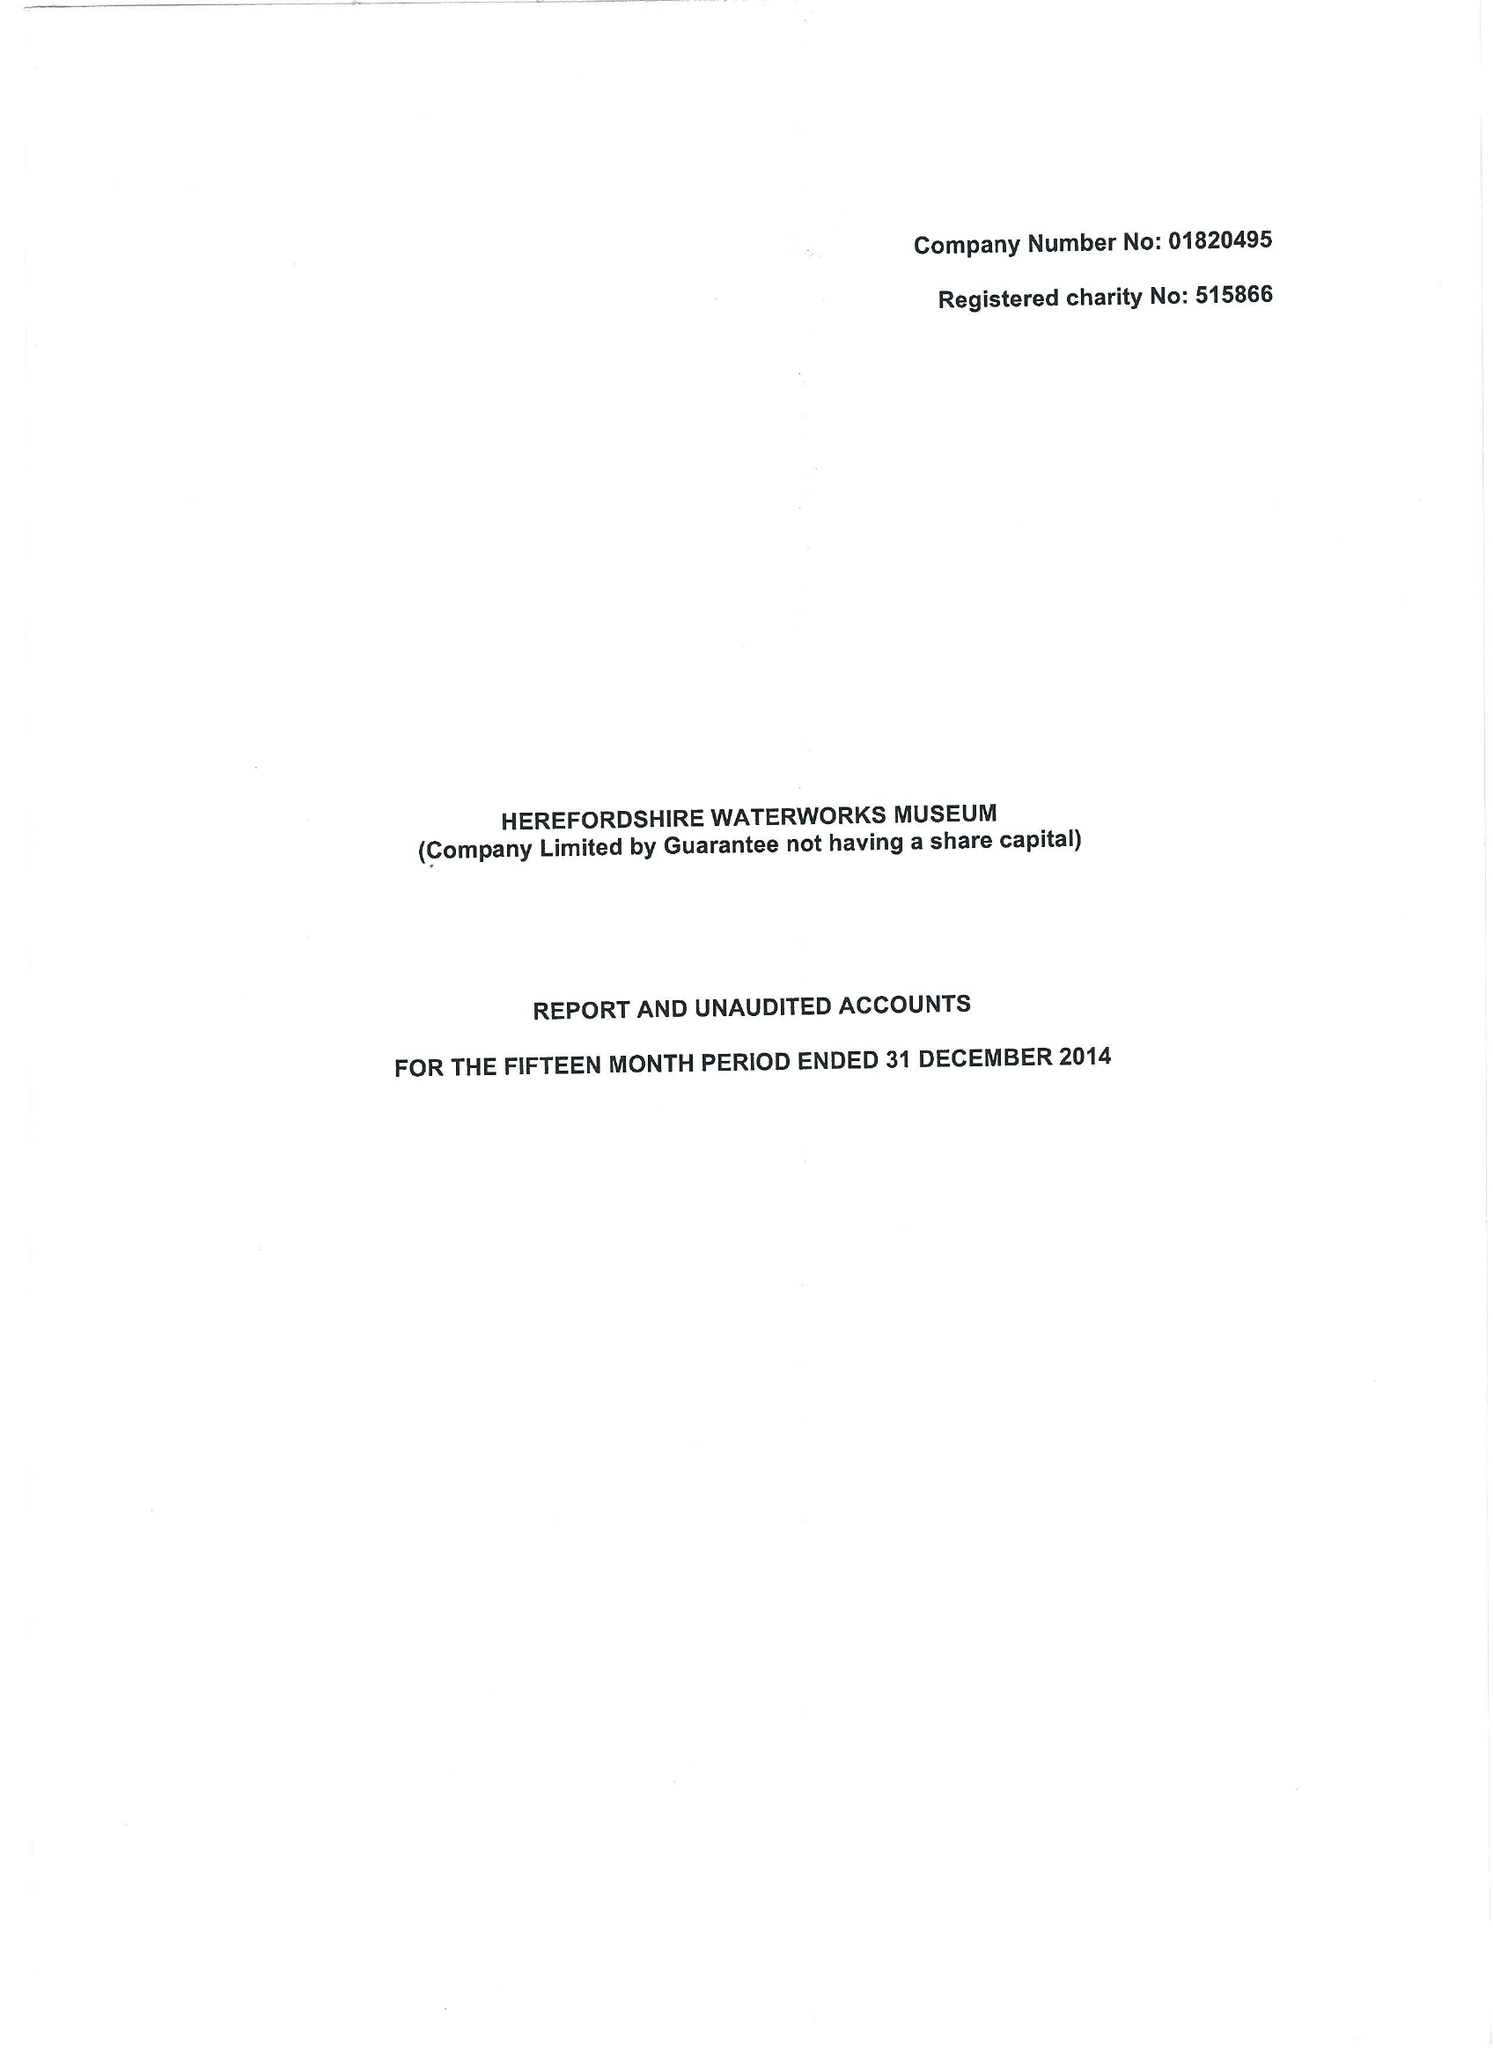What is the value for the income_annually_in_british_pounds?
Answer the question using a single word or phrase. 69765.00 